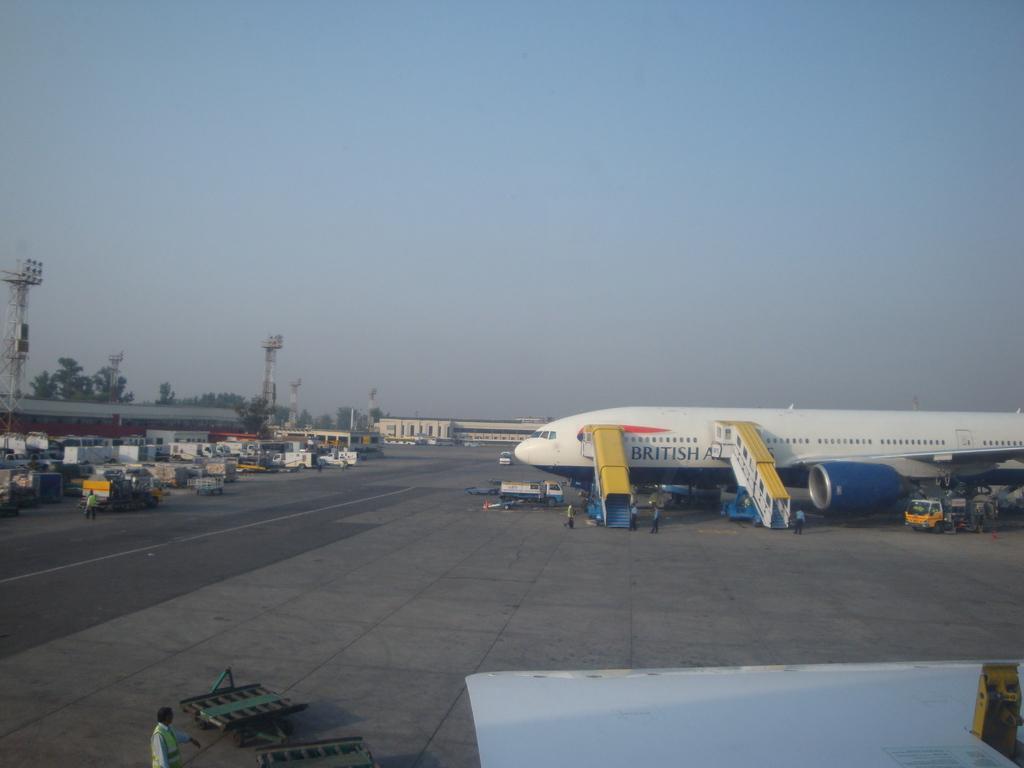How would you summarize this image in a sentence or two? In the image there is an airplane in the airport landing area, around the airport there are many vehicles and other equipment like trolleys and around the vehicles there are two towers, a building and in the background there are few trees. 